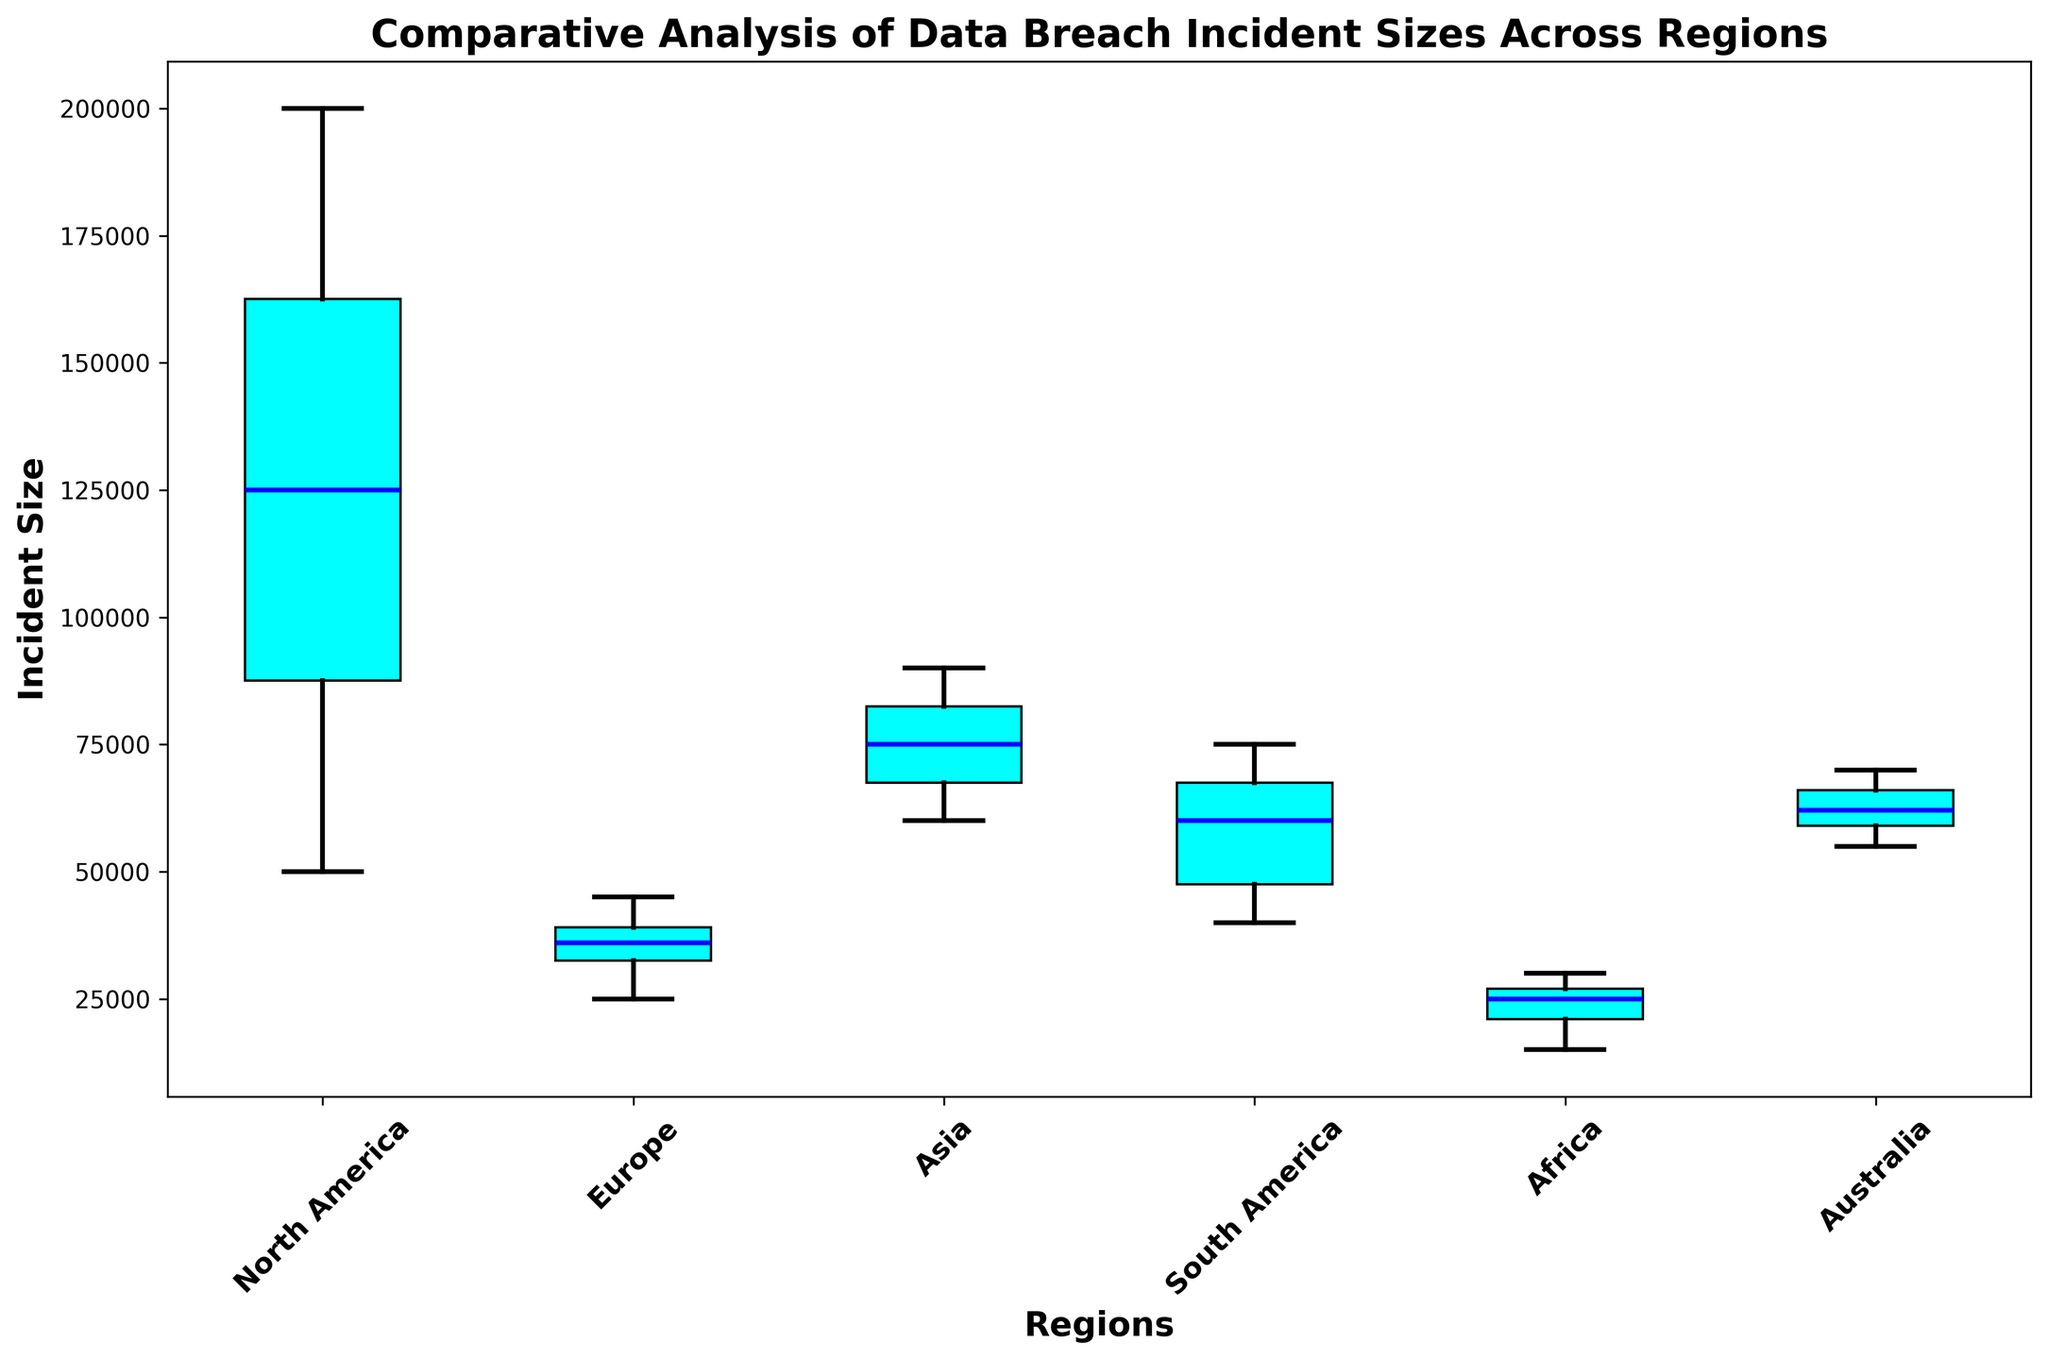What is the region with the highest median incident size? First, locate the median lines (blue) in each box plot. The region with the highest median line represents the highest median incident size.
Answer: North America Which region has the lowest lower whisker value for incident sizes? Identify the bottom whiskers of each box plot. The region with the lowest bottom whisker corresponds to the lowest lower whisker value.
Answer: Africa Compare the median incident sizes between North America and Europe. Which one is higher? Locate the median (blue) lines for both North America and Europe. The region with the higher median line has the higher median incident size.
Answer: North America What is the interquartile range (IQR) of Asia? The IQR is the difference between the upper quartile (top edge of the box) and lower quartile (bottom edge of the box). Subtract the lower quartile from the upper quartile for Asia.
Answer: 15000 Which regions have outliers? Find the red markers outside the whiskers. The regions whose box plots have these red markers are the ones with outliers.
Answer: North America, South America, Australia Is the variability in incident sizes greater in North America or Africa? Compare the length of the boxes and whiskers in North America and Africa. The region with the larger range (from bottom whisker to top whisker) indicates greater variability.
Answer: North America Which region’s box plot has the shortest interquartile range (IQR)? Compare the lengths of the boxes across all regions. The region with the shortest box length has the shortest IQR.
Answer: Europe How does the maximum incident size in Australia compare to that in South America? Identify the top whiskers in the box plots for both regions. Compare their lengths to determine which has the higher maximum incident size.
Answer: South America What is the approximate range of incident sizes in Africa? The range is determined by the distance between the bottom and top whiskers. Note the values at these points in Africa's box plot.
Answer: 15000 - 30000 